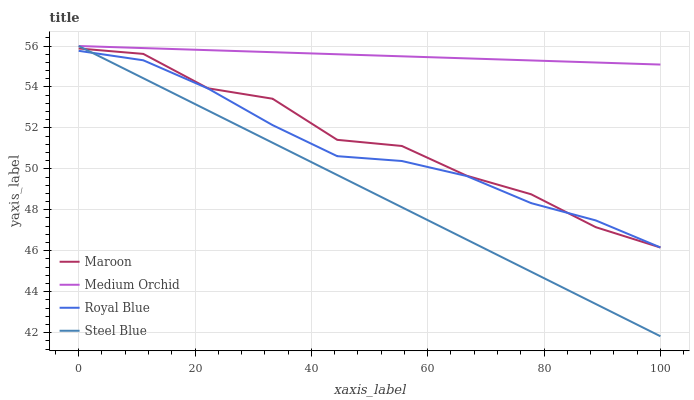Does Steel Blue have the minimum area under the curve?
Answer yes or no. Yes. Does Medium Orchid have the maximum area under the curve?
Answer yes or no. Yes. Does Medium Orchid have the minimum area under the curve?
Answer yes or no. No. Does Steel Blue have the maximum area under the curve?
Answer yes or no. No. Is Medium Orchid the smoothest?
Answer yes or no. Yes. Is Maroon the roughest?
Answer yes or no. Yes. Is Steel Blue the smoothest?
Answer yes or no. No. Is Steel Blue the roughest?
Answer yes or no. No. Does Steel Blue have the lowest value?
Answer yes or no. Yes. Does Medium Orchid have the lowest value?
Answer yes or no. No. Does Steel Blue have the highest value?
Answer yes or no. Yes. Does Maroon have the highest value?
Answer yes or no. No. Is Royal Blue less than Medium Orchid?
Answer yes or no. Yes. Is Medium Orchid greater than Maroon?
Answer yes or no. Yes. Does Maroon intersect Steel Blue?
Answer yes or no. Yes. Is Maroon less than Steel Blue?
Answer yes or no. No. Is Maroon greater than Steel Blue?
Answer yes or no. No. Does Royal Blue intersect Medium Orchid?
Answer yes or no. No. 